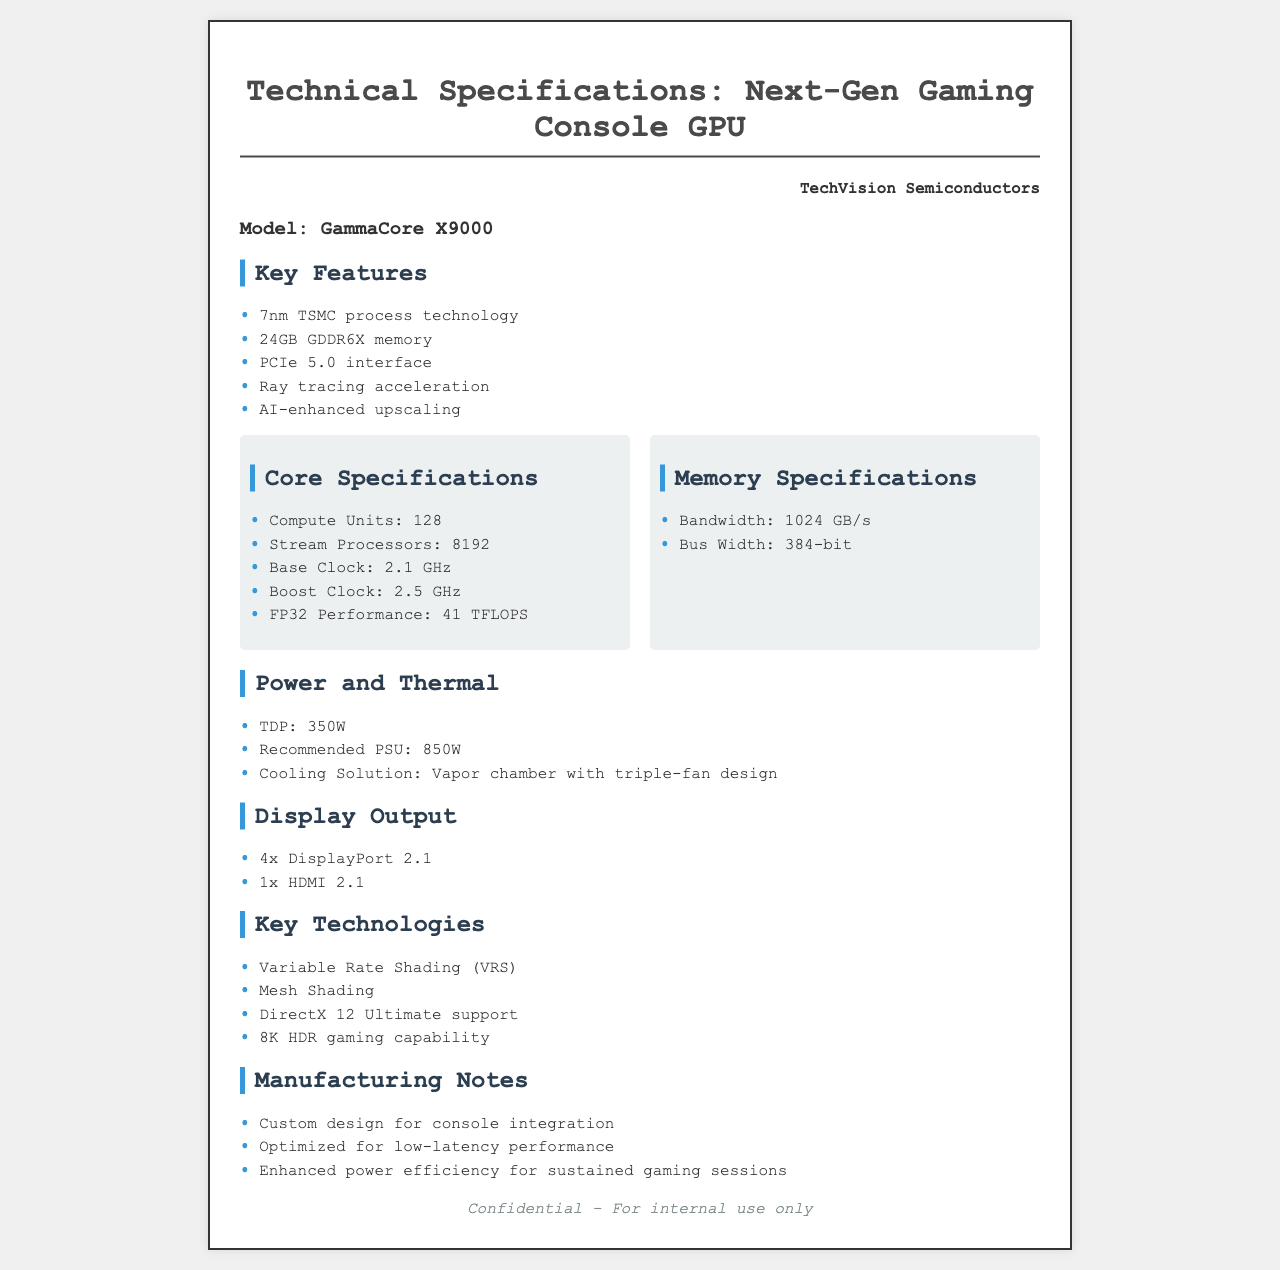What is the manufacturing company for the GPU? The document mentions "TechVision Semiconductors" as the manufacturer of the GPU.
Answer: TechVision Semiconductors What is the model name of the GPU? The model name of the GPU is provided under the "Model" section in the document.
Answer: GammaCore X9000 What is the memory type used in the GPU? The document specifies the memory type as "GDDR6X" under the Key Features section.
Answer: GDDR6X What is the TDP of the GPU? The "Power and Thermal" section states the Thermal Design Power (TDP) value.
Answer: 350W How many compute units does the GPU have? The Core Specifications section lists the number of compute units for the GPU.
Answer: 128 What is the base clock speed of the GPU? The document provides the base clock speed in the Core Specifications section.
Answer: 2.1 GHz What technology supports 8K HDR gaming capability? The Key Technologies section indicates that 8K HDR gaming capability is one of the features.
Answer: 8K HDR gaming capability How much memory bandwidth does the GPU have? The Memory Specifications section provides the memory bandwidth for the GPU.
Answer: 1024 GB/s What cooling solution is mentioned for the GPU? The Power and Thermal section describes the cooling solution used for thermal management.
Answer: Vapor chamber with triple-fan design 